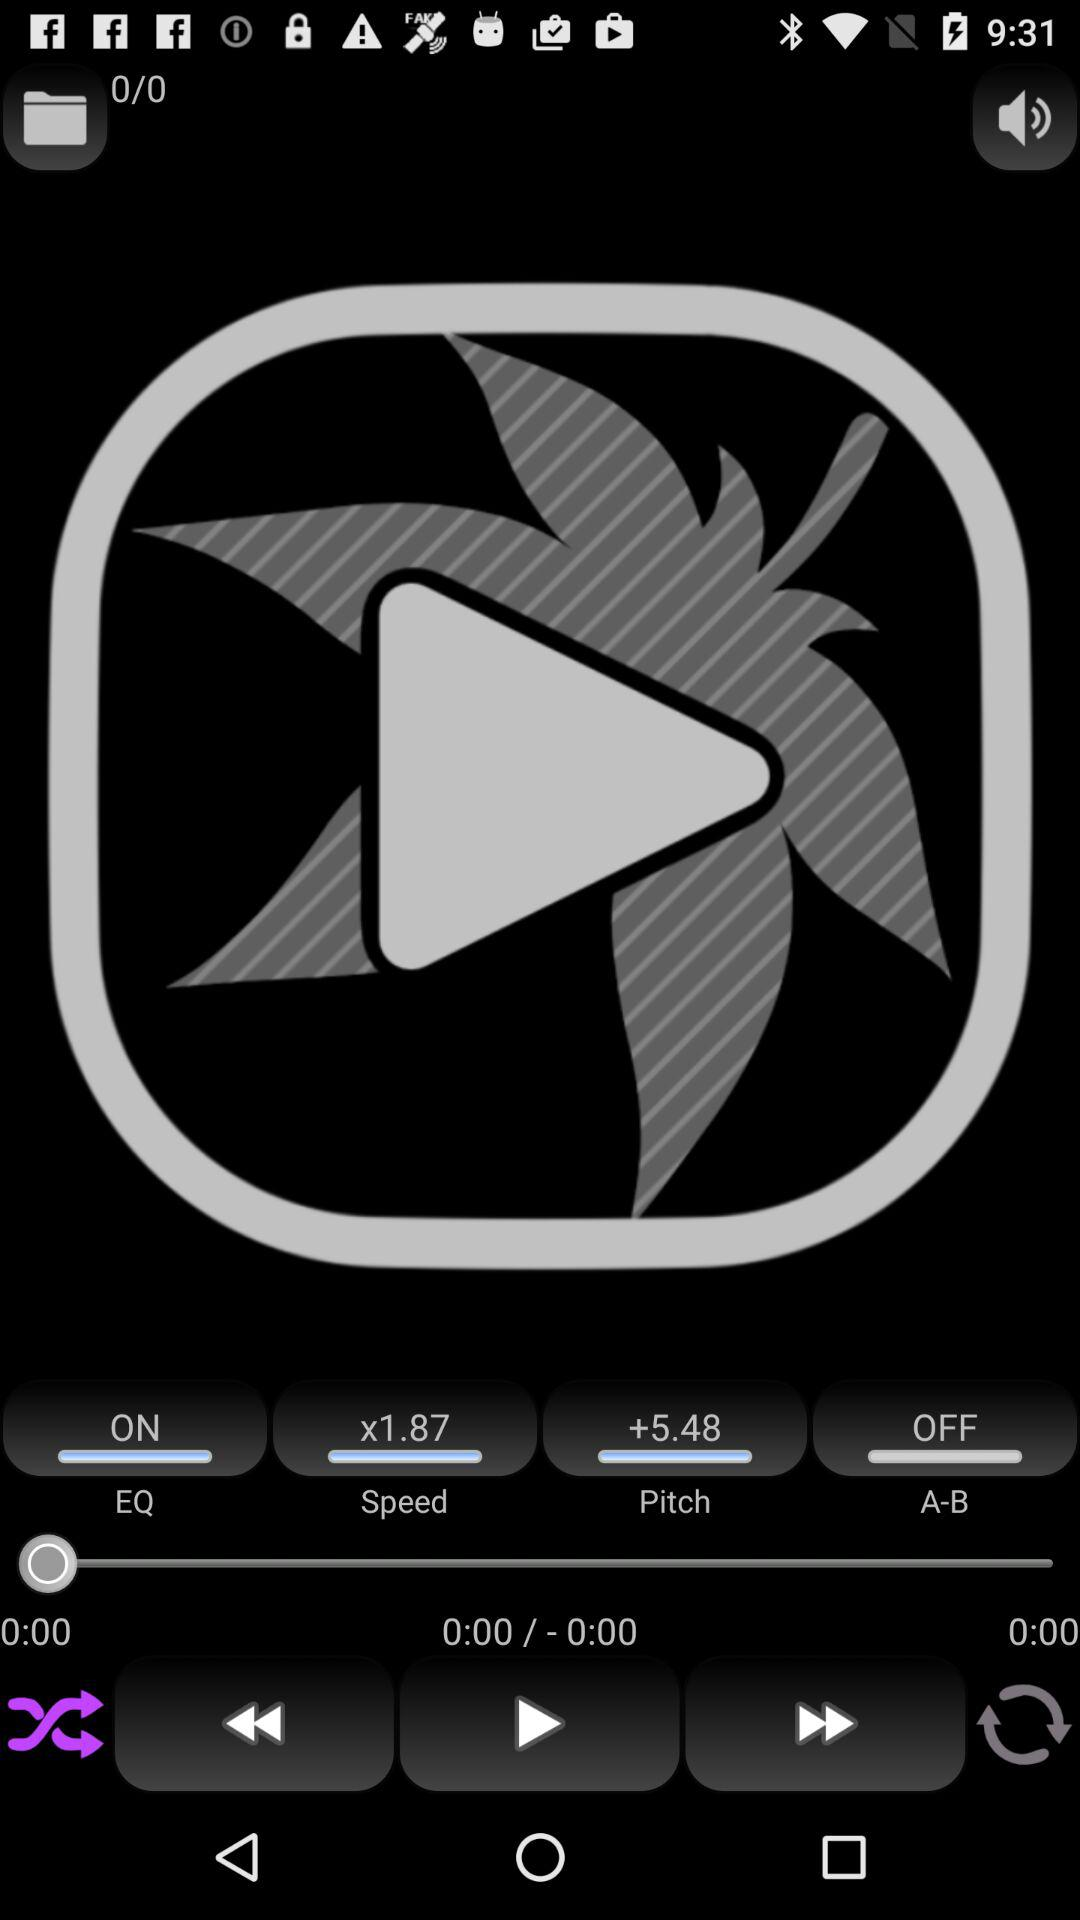What is "Pitch"?
Answer the question using a single word or phrase. "Pitch" is +5.48. 